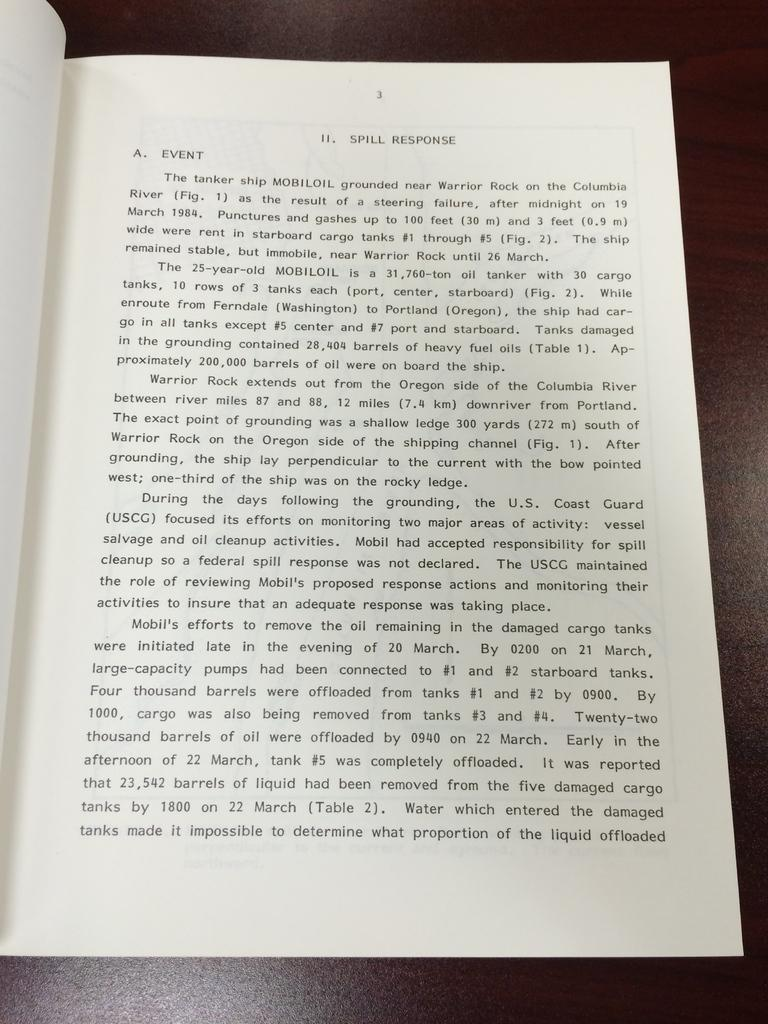<image>
Describe the image concisely. A book is opened to chapter II. Spill Response 